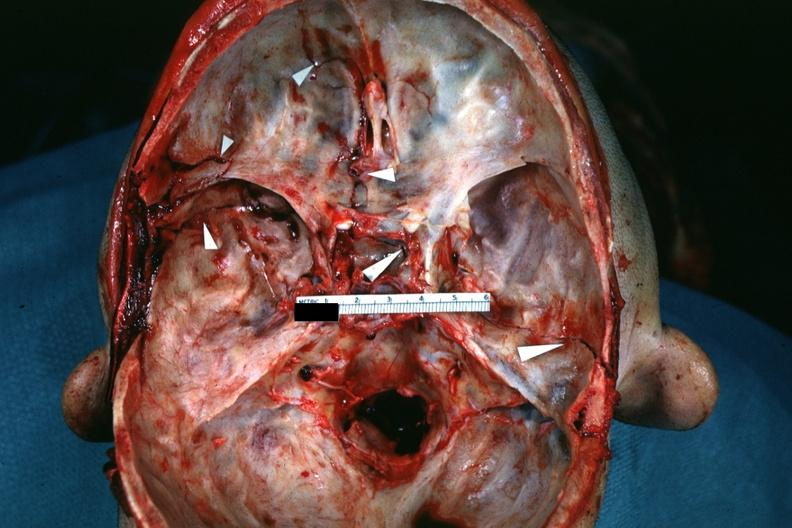what is present?
Answer the question using a single word or phrase. Basilar skull fracture 